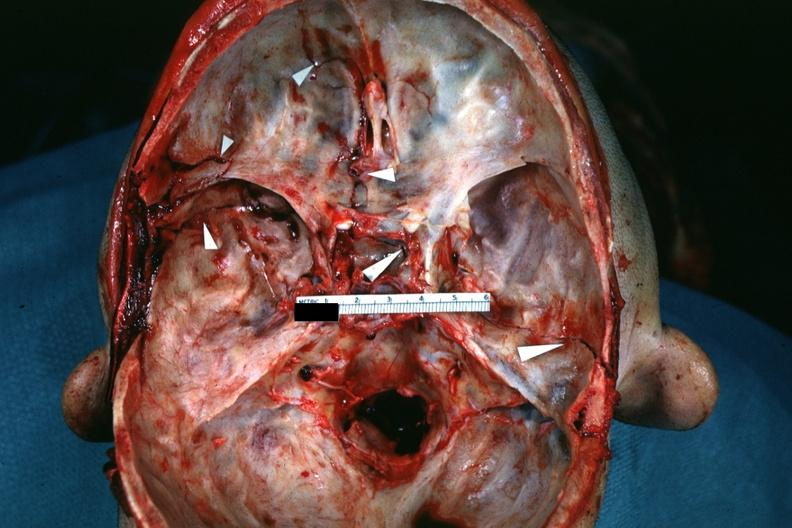what is present?
Answer the question using a single word or phrase. Basilar skull fracture 